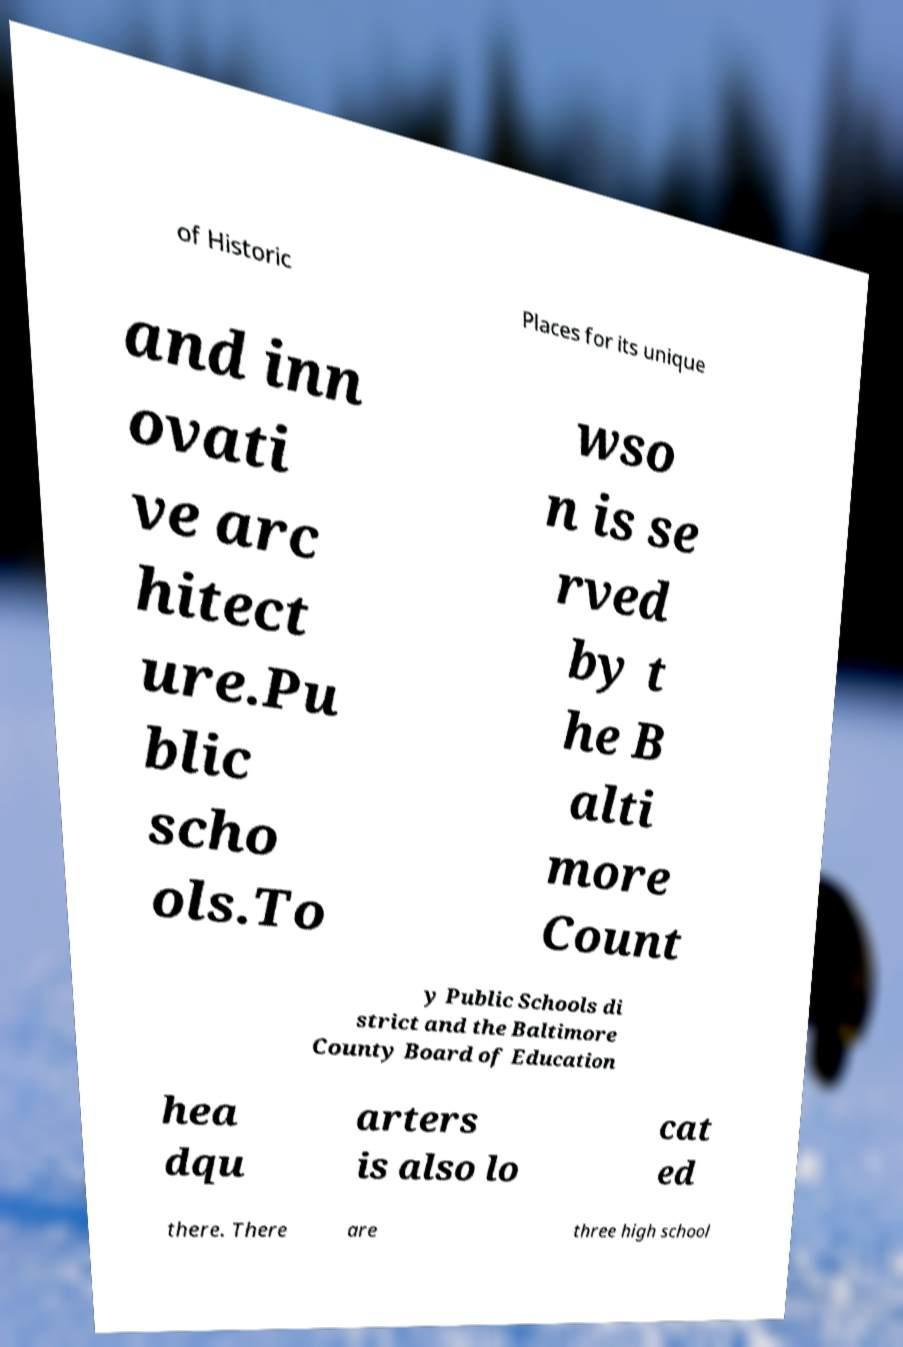For documentation purposes, I need the text within this image transcribed. Could you provide that? of Historic Places for its unique and inn ovati ve arc hitect ure.Pu blic scho ols.To wso n is se rved by t he B alti more Count y Public Schools di strict and the Baltimore County Board of Education hea dqu arters is also lo cat ed there. There are three high school 